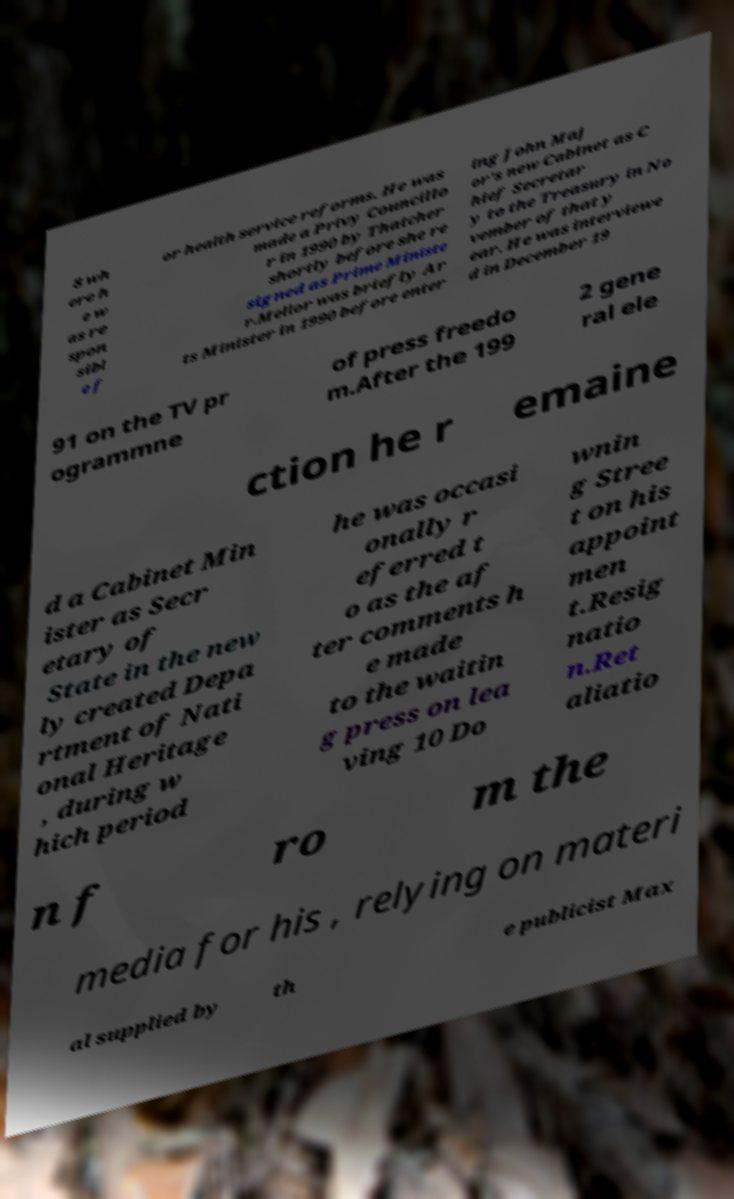For documentation purposes, I need the text within this image transcribed. Could you provide that? 8 wh ere h e w as re spon sibl e f or health service reforms. He was made a Privy Councillo r in 1990 by Thatcher shortly before she re signed as Prime Ministe r.Mellor was briefly Ar ts Minister in 1990 before enter ing John Maj or's new Cabinet as C hief Secretar y to the Treasury in No vember of that y ear. He was interviewe d in December 19 91 on the TV pr ogrammne of press freedo m.After the 199 2 gene ral ele ction he r emaine d a Cabinet Min ister as Secr etary of State in the new ly created Depa rtment of Nati onal Heritage , during w hich period he was occasi onally r eferred t o as the af ter comments h e made to the waitin g press on lea ving 10 Do wnin g Stree t on his appoint men t.Resig natio n.Ret aliatio n f ro m the media for his , relying on materi al supplied by th e publicist Max 